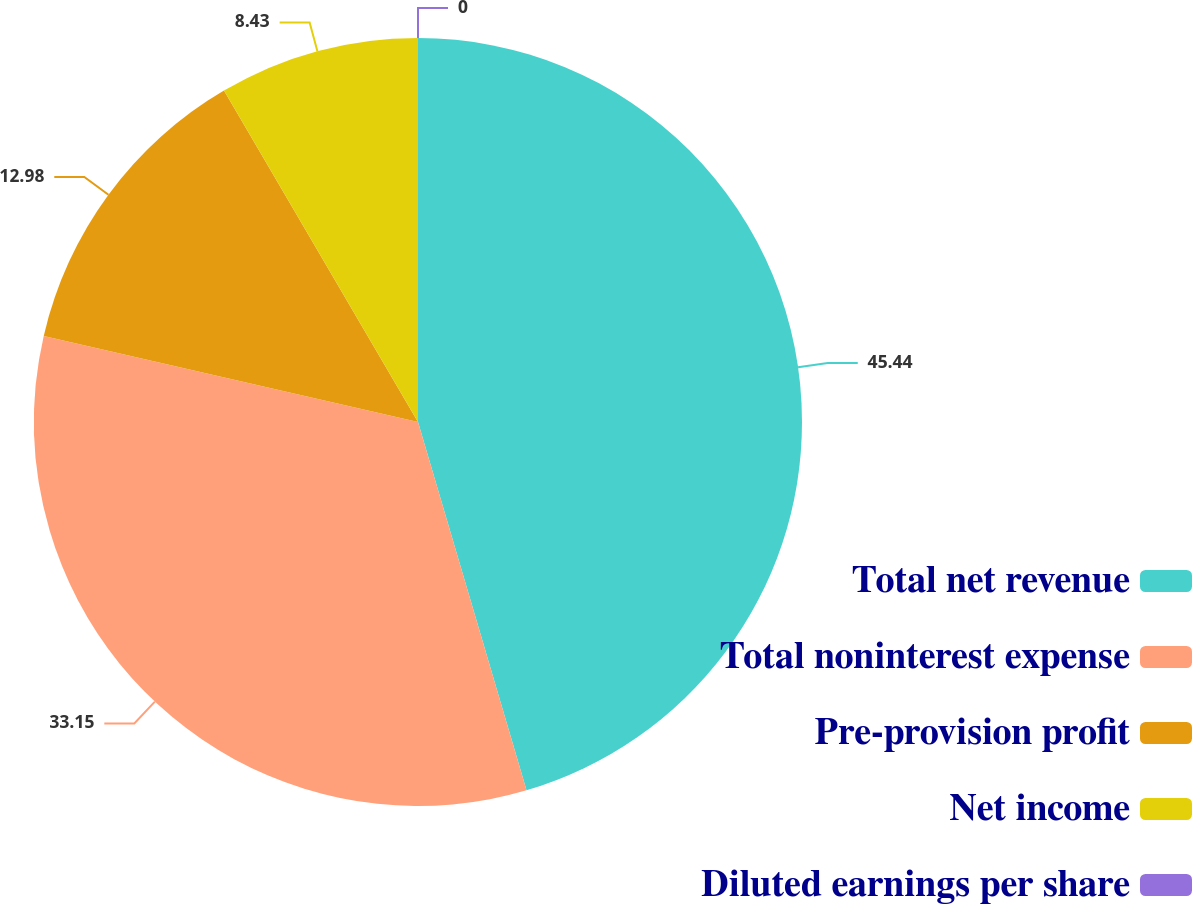<chart> <loc_0><loc_0><loc_500><loc_500><pie_chart><fcel>Total net revenue<fcel>Total noninterest expense<fcel>Pre-provision profit<fcel>Net income<fcel>Diluted earnings per share<nl><fcel>45.44%<fcel>33.15%<fcel>12.98%<fcel>8.43%<fcel>0.0%<nl></chart> 